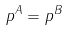<formula> <loc_0><loc_0><loc_500><loc_500>p ^ { A } = p ^ { B }</formula> 